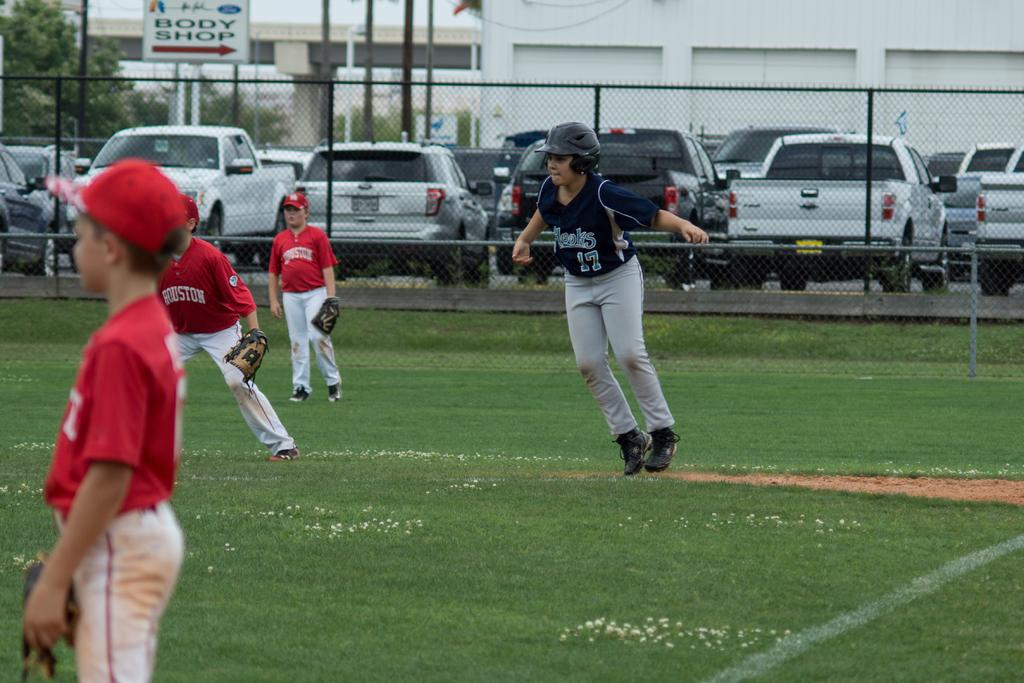<image>
Offer a succinct explanation of the picture presented. The team in red jersey is the Team Houston. 